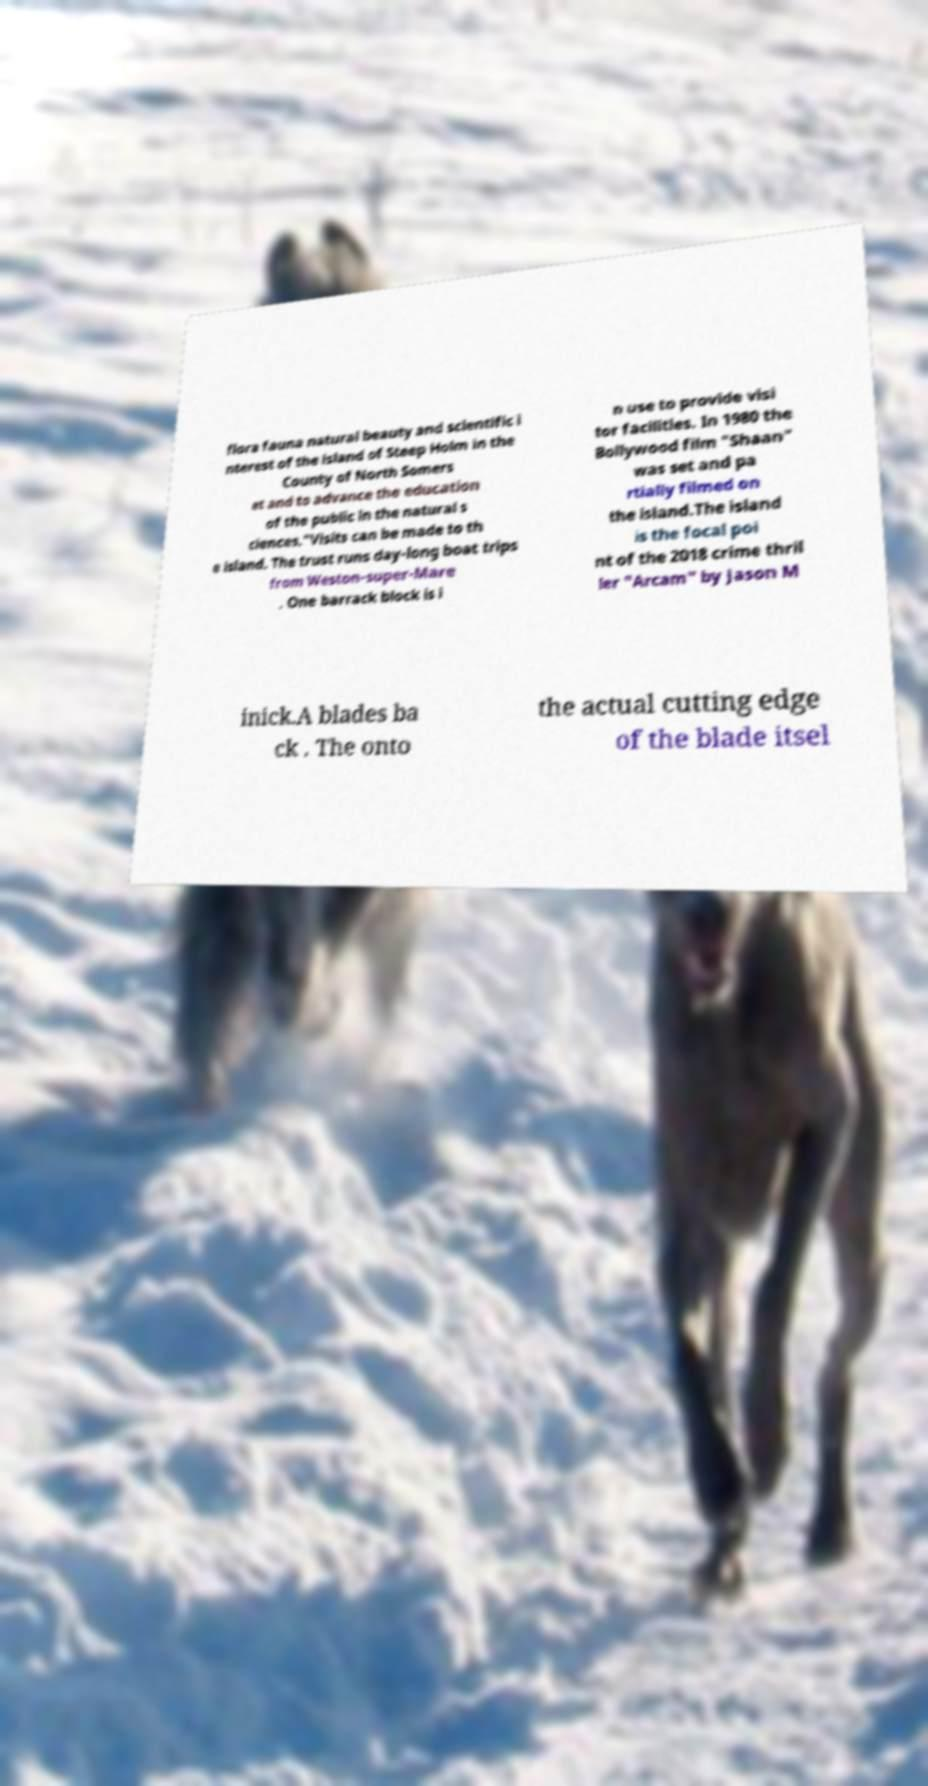What messages or text are displayed in this image? I need them in a readable, typed format. flora fauna natural beauty and scientific i nterest of the island of Steep Holm in the County of North Somers et and to advance the education of the public in the natural s ciences."Visits can be made to th e island. The trust runs day-long boat trips from Weston-super-Mare . One barrack block is i n use to provide visi tor facilities. In 1980 the Bollywood film "Shaan" was set and pa rtially filmed on the island.The island is the focal poi nt of the 2018 crime thril ler "Arcam" by Jason M inick.A blades ba ck . The onto the actual cutting edge of the blade itsel 